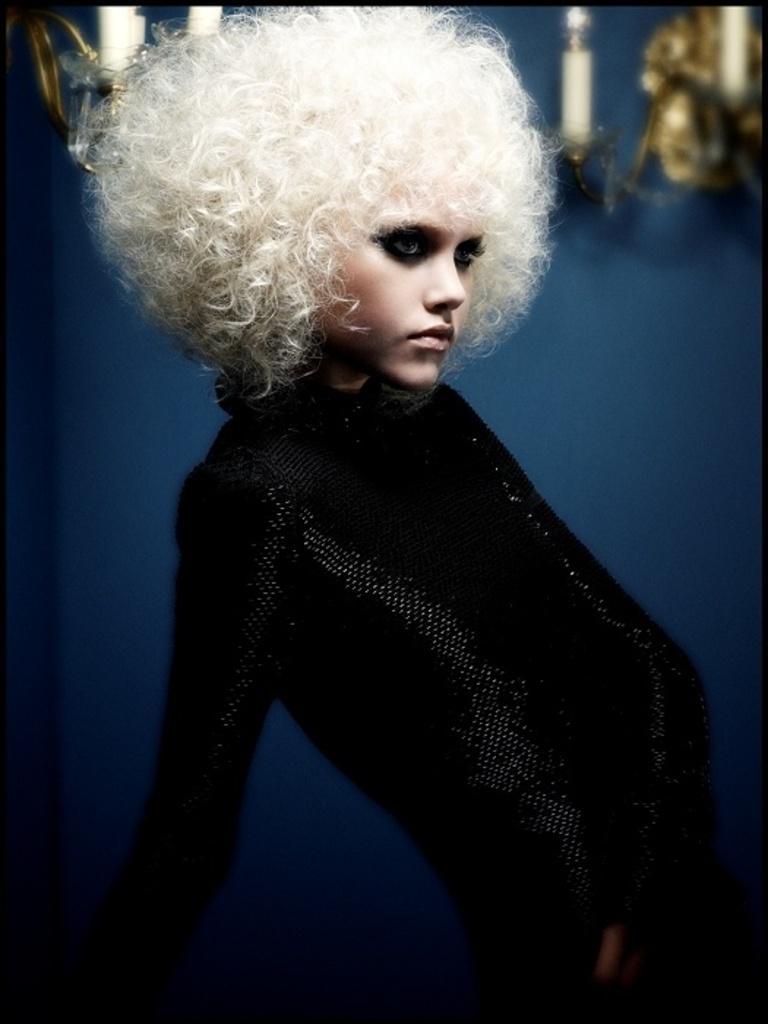How would you summarize this image in a sentence or two? The girl in this picture is wearing a black dress. Behind her, we see a wall in blue color and we even see something in white color. At the bottom of the picture, it is black in color. 